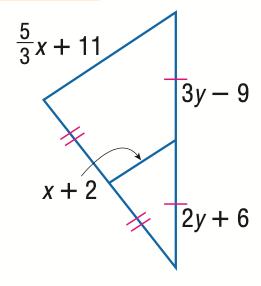Answer the mathemtical geometry problem and directly provide the correct option letter.
Question: Find x.
Choices: A: 12 B: 15 C: 18 D: 21 D 